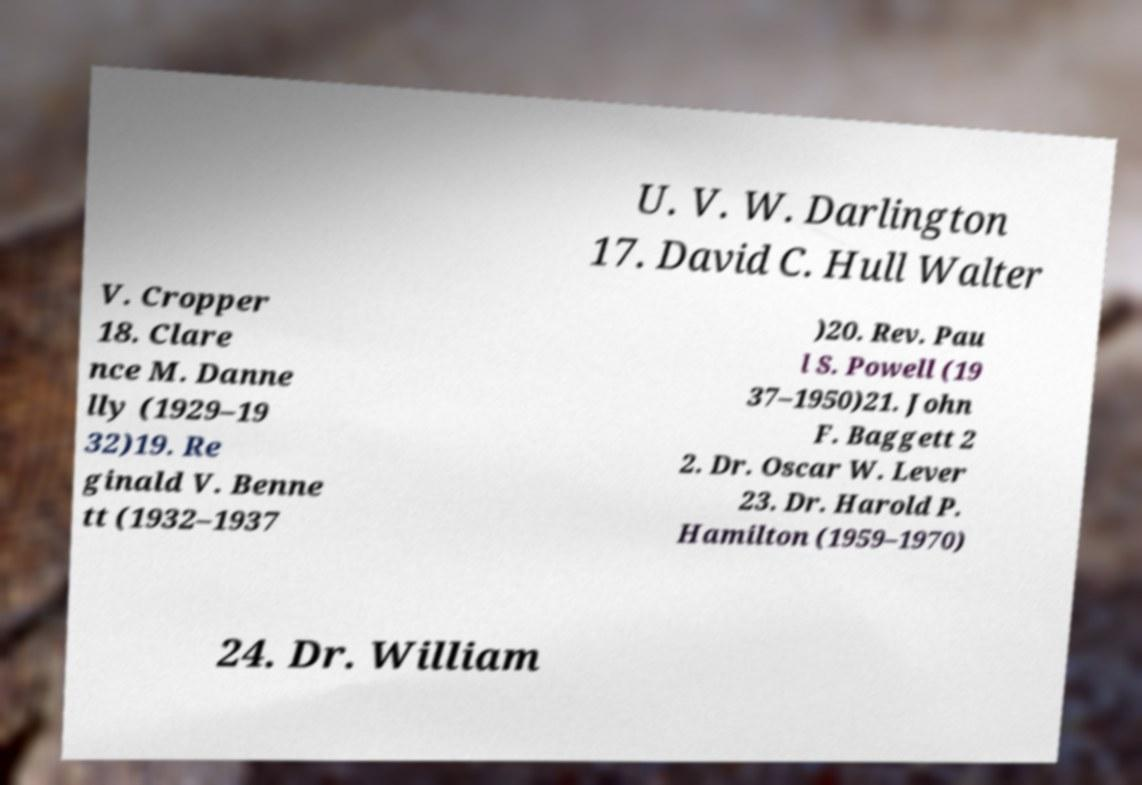I need the written content from this picture converted into text. Can you do that? U. V. W. Darlington 17. David C. Hull Walter V. Cropper 18. Clare nce M. Danne lly (1929–19 32)19. Re ginald V. Benne tt (1932–1937 )20. Rev. Pau l S. Powell (19 37–1950)21. John F. Baggett 2 2. Dr. Oscar W. Lever 23. Dr. Harold P. Hamilton (1959–1970) 24. Dr. William 